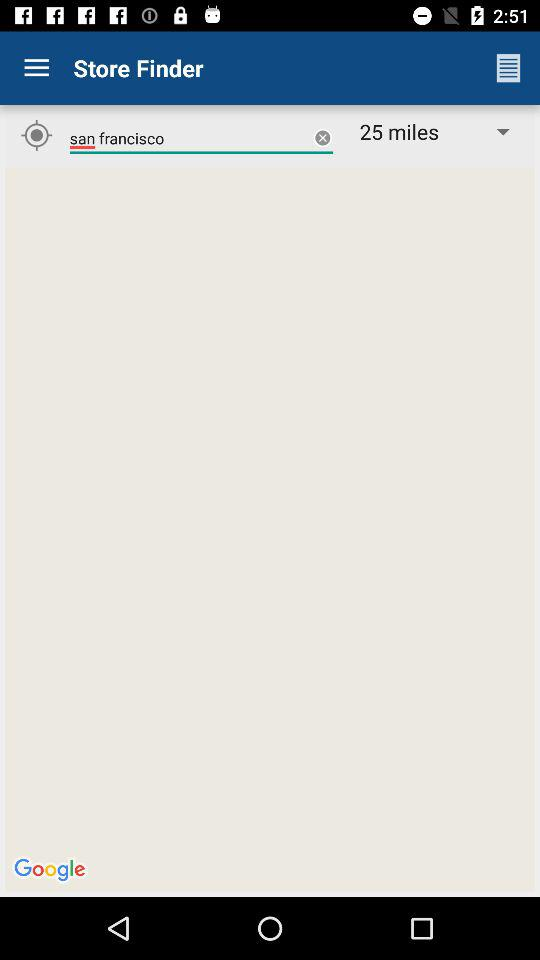What city is entered? The entered city is San Francisco. 